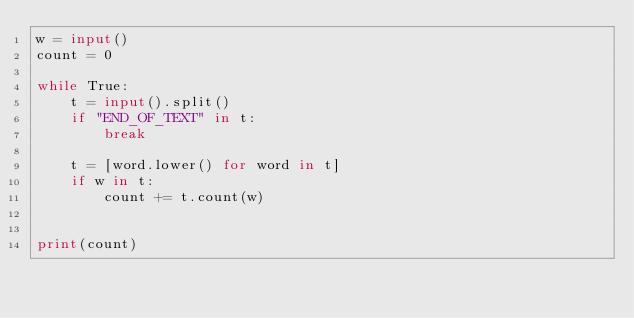<code> <loc_0><loc_0><loc_500><loc_500><_Python_>w = input()
count = 0

while True:
    t = input().split()
    if "END_OF_TEXT" in t:
        break

    t = [word.lower() for word in t]
    if w in t:
        count += t.count(w)

    
print(count)
</code> 